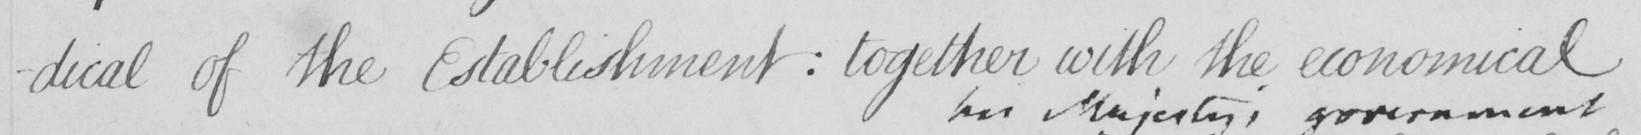What text is written in this handwritten line? -dical of the Establishment  :  together with the economical 